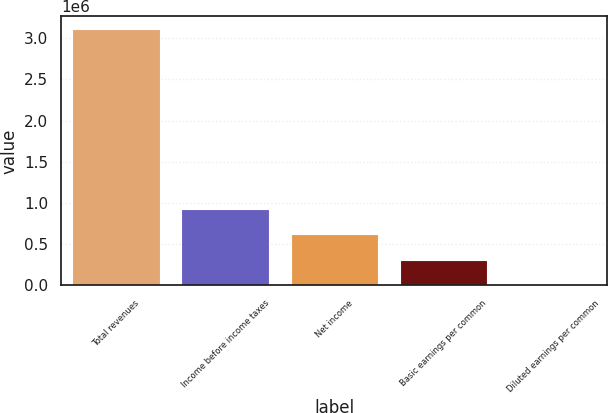Convert chart to OTSL. <chart><loc_0><loc_0><loc_500><loc_500><bar_chart><fcel>Total revenues<fcel>Income before income taxes<fcel>Net income<fcel>Basic earnings per common<fcel>Diluted earnings per common<nl><fcel>3.11176e+06<fcel>933530<fcel>622353<fcel>311177<fcel>0.38<nl></chart> 